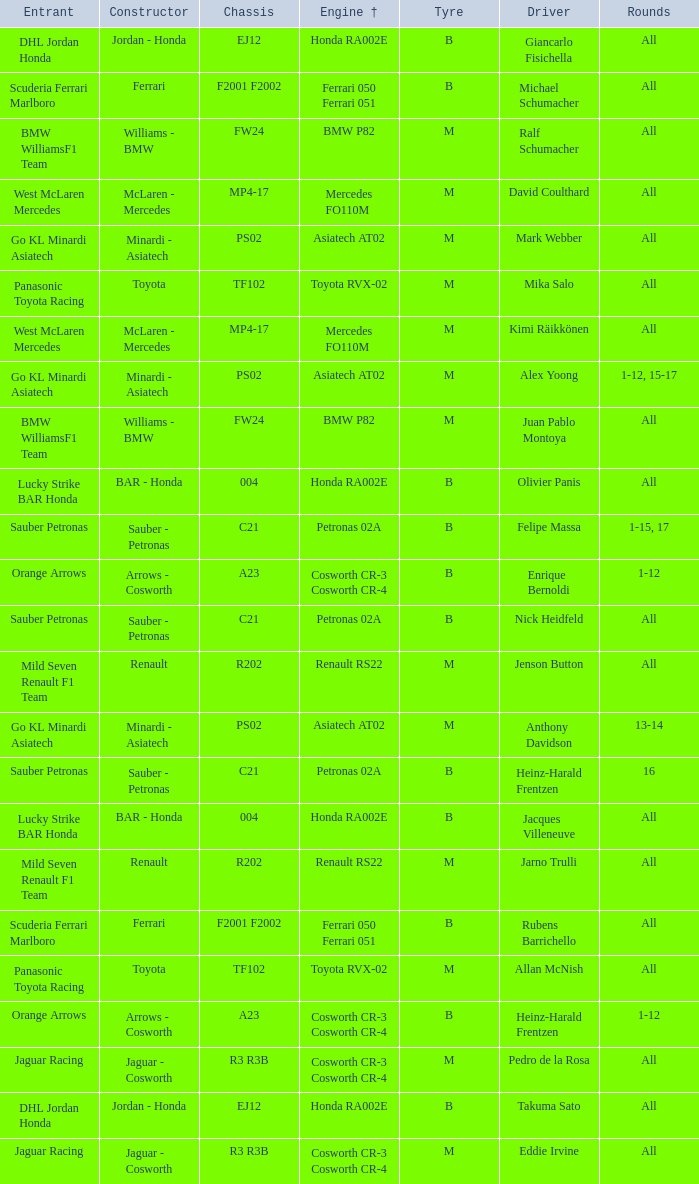What is the engine when the rounds ar all, the tyre is m and the driver is david coulthard? Mercedes FO110M. 